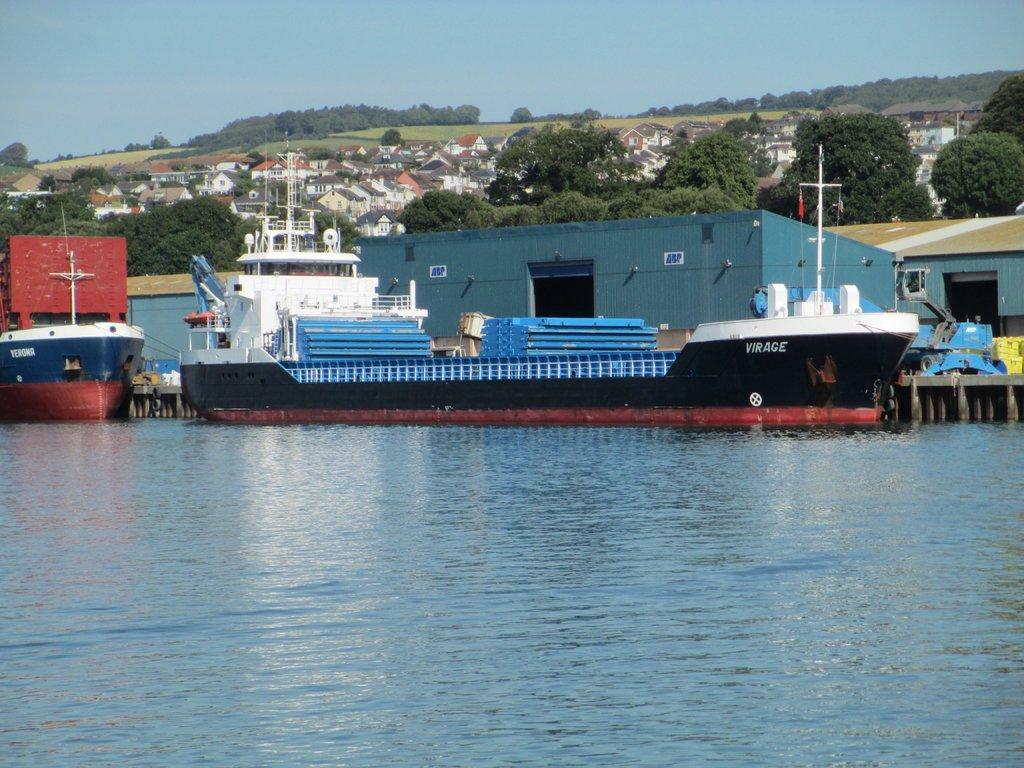In one or two sentences, can you explain what this image depicts? In the foreground of this image, there is water. In the middle, there are ships. Behind it, there are shelters, trees, buildings, grassland and at the top, there is the sky. 